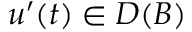<formula> <loc_0><loc_0><loc_500><loc_500>u ^ { \prime } ( t ) \in D ( B )</formula> 